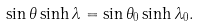<formula> <loc_0><loc_0><loc_500><loc_500>\sin \theta \sinh \lambda = \sin \theta _ { 0 } \sinh \lambda _ { 0 } .</formula> 